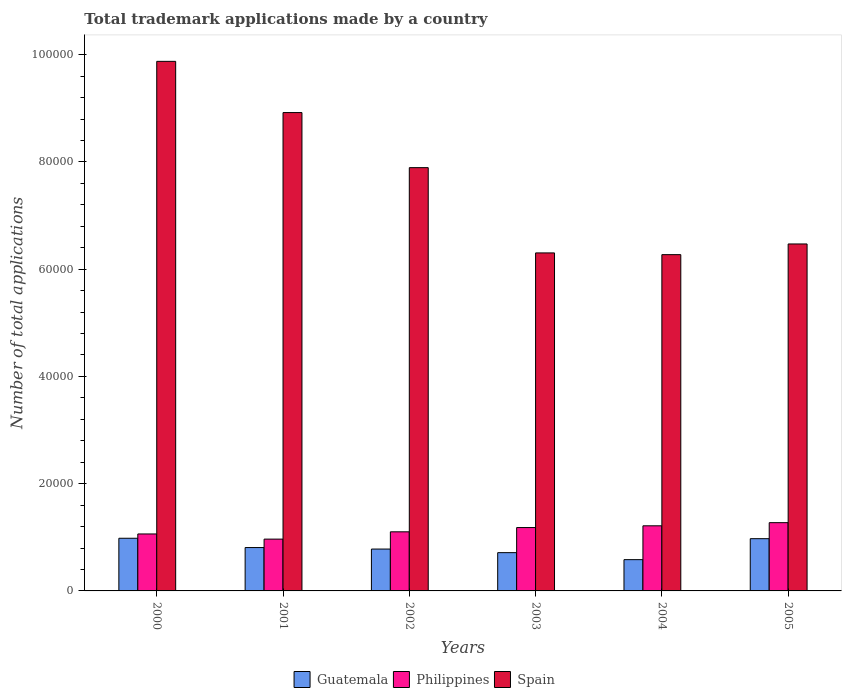Are the number of bars on each tick of the X-axis equal?
Offer a very short reply. Yes. What is the label of the 6th group of bars from the left?
Make the answer very short. 2005. What is the number of applications made by in Spain in 2003?
Provide a succinct answer. 6.30e+04. Across all years, what is the maximum number of applications made by in Guatemala?
Ensure brevity in your answer.  9821. Across all years, what is the minimum number of applications made by in Spain?
Offer a terse response. 6.27e+04. In which year was the number of applications made by in Philippines minimum?
Make the answer very short. 2001. What is the total number of applications made by in Guatemala in the graph?
Offer a terse response. 4.84e+04. What is the difference between the number of applications made by in Guatemala in 2002 and that in 2004?
Keep it short and to the point. 1976. What is the difference between the number of applications made by in Philippines in 2003 and the number of applications made by in Spain in 2002?
Make the answer very short. -6.71e+04. What is the average number of applications made by in Spain per year?
Provide a succinct answer. 7.62e+04. In the year 2004, what is the difference between the number of applications made by in Guatemala and number of applications made by in Spain?
Your answer should be compact. -5.69e+04. What is the ratio of the number of applications made by in Guatemala in 2000 to that in 2001?
Offer a terse response. 1.21. What is the difference between the highest and the second highest number of applications made by in Spain?
Offer a very short reply. 9551. What is the difference between the highest and the lowest number of applications made by in Spain?
Keep it short and to the point. 3.60e+04. In how many years, is the number of applications made by in Spain greater than the average number of applications made by in Spain taken over all years?
Make the answer very short. 3. What does the 3rd bar from the left in 2005 represents?
Provide a succinct answer. Spain. What does the 2nd bar from the right in 2005 represents?
Provide a short and direct response. Philippines. Is it the case that in every year, the sum of the number of applications made by in Guatemala and number of applications made by in Spain is greater than the number of applications made by in Philippines?
Offer a very short reply. Yes. Are all the bars in the graph horizontal?
Your response must be concise. No. What is the difference between two consecutive major ticks on the Y-axis?
Keep it short and to the point. 2.00e+04. How are the legend labels stacked?
Make the answer very short. Horizontal. What is the title of the graph?
Provide a succinct answer. Total trademark applications made by a country. What is the label or title of the Y-axis?
Give a very brief answer. Number of total applications. What is the Number of total applications in Guatemala in 2000?
Offer a terse response. 9821. What is the Number of total applications in Philippines in 2000?
Ensure brevity in your answer.  1.06e+04. What is the Number of total applications of Spain in 2000?
Your response must be concise. 9.88e+04. What is the Number of total applications of Guatemala in 2001?
Keep it short and to the point. 8088. What is the Number of total applications of Philippines in 2001?
Make the answer very short. 9661. What is the Number of total applications in Spain in 2001?
Offer a very short reply. 8.92e+04. What is the Number of total applications in Guatemala in 2002?
Offer a very short reply. 7808. What is the Number of total applications of Philippines in 2002?
Your answer should be compact. 1.10e+04. What is the Number of total applications in Spain in 2002?
Your answer should be very brief. 7.89e+04. What is the Number of total applications of Guatemala in 2003?
Offer a terse response. 7138. What is the Number of total applications in Philippines in 2003?
Give a very brief answer. 1.18e+04. What is the Number of total applications in Spain in 2003?
Offer a terse response. 6.30e+04. What is the Number of total applications in Guatemala in 2004?
Offer a very short reply. 5832. What is the Number of total applications in Philippines in 2004?
Provide a short and direct response. 1.21e+04. What is the Number of total applications of Spain in 2004?
Provide a short and direct response. 6.27e+04. What is the Number of total applications in Guatemala in 2005?
Give a very brief answer. 9743. What is the Number of total applications of Philippines in 2005?
Give a very brief answer. 1.27e+04. What is the Number of total applications of Spain in 2005?
Provide a succinct answer. 6.47e+04. Across all years, what is the maximum Number of total applications of Guatemala?
Offer a terse response. 9821. Across all years, what is the maximum Number of total applications in Philippines?
Offer a very short reply. 1.27e+04. Across all years, what is the maximum Number of total applications in Spain?
Your response must be concise. 9.88e+04. Across all years, what is the minimum Number of total applications in Guatemala?
Your answer should be compact. 5832. Across all years, what is the minimum Number of total applications of Philippines?
Provide a succinct answer. 9661. Across all years, what is the minimum Number of total applications of Spain?
Keep it short and to the point. 6.27e+04. What is the total Number of total applications of Guatemala in the graph?
Your response must be concise. 4.84e+04. What is the total Number of total applications of Philippines in the graph?
Make the answer very short. 6.80e+04. What is the total Number of total applications in Spain in the graph?
Your response must be concise. 4.57e+05. What is the difference between the Number of total applications of Guatemala in 2000 and that in 2001?
Provide a short and direct response. 1733. What is the difference between the Number of total applications of Philippines in 2000 and that in 2001?
Your answer should be very brief. 962. What is the difference between the Number of total applications in Spain in 2000 and that in 2001?
Ensure brevity in your answer.  9551. What is the difference between the Number of total applications in Guatemala in 2000 and that in 2002?
Provide a succinct answer. 2013. What is the difference between the Number of total applications of Philippines in 2000 and that in 2002?
Provide a short and direct response. -398. What is the difference between the Number of total applications of Spain in 2000 and that in 2002?
Offer a terse response. 1.98e+04. What is the difference between the Number of total applications of Guatemala in 2000 and that in 2003?
Your answer should be very brief. 2683. What is the difference between the Number of total applications of Philippines in 2000 and that in 2003?
Make the answer very short. -1193. What is the difference between the Number of total applications in Spain in 2000 and that in 2003?
Offer a terse response. 3.57e+04. What is the difference between the Number of total applications of Guatemala in 2000 and that in 2004?
Offer a very short reply. 3989. What is the difference between the Number of total applications in Philippines in 2000 and that in 2004?
Offer a terse response. -1519. What is the difference between the Number of total applications in Spain in 2000 and that in 2004?
Offer a very short reply. 3.60e+04. What is the difference between the Number of total applications of Philippines in 2000 and that in 2005?
Provide a short and direct response. -2106. What is the difference between the Number of total applications of Spain in 2000 and that in 2005?
Your answer should be very brief. 3.41e+04. What is the difference between the Number of total applications in Guatemala in 2001 and that in 2002?
Offer a terse response. 280. What is the difference between the Number of total applications of Philippines in 2001 and that in 2002?
Provide a short and direct response. -1360. What is the difference between the Number of total applications in Spain in 2001 and that in 2002?
Ensure brevity in your answer.  1.03e+04. What is the difference between the Number of total applications of Guatemala in 2001 and that in 2003?
Your response must be concise. 950. What is the difference between the Number of total applications in Philippines in 2001 and that in 2003?
Offer a terse response. -2155. What is the difference between the Number of total applications of Spain in 2001 and that in 2003?
Provide a succinct answer. 2.62e+04. What is the difference between the Number of total applications in Guatemala in 2001 and that in 2004?
Your answer should be very brief. 2256. What is the difference between the Number of total applications of Philippines in 2001 and that in 2004?
Provide a short and direct response. -2481. What is the difference between the Number of total applications of Spain in 2001 and that in 2004?
Your response must be concise. 2.65e+04. What is the difference between the Number of total applications in Guatemala in 2001 and that in 2005?
Keep it short and to the point. -1655. What is the difference between the Number of total applications of Philippines in 2001 and that in 2005?
Provide a short and direct response. -3068. What is the difference between the Number of total applications of Spain in 2001 and that in 2005?
Provide a short and direct response. 2.45e+04. What is the difference between the Number of total applications in Guatemala in 2002 and that in 2003?
Ensure brevity in your answer.  670. What is the difference between the Number of total applications in Philippines in 2002 and that in 2003?
Your answer should be very brief. -795. What is the difference between the Number of total applications of Spain in 2002 and that in 2003?
Give a very brief answer. 1.59e+04. What is the difference between the Number of total applications of Guatemala in 2002 and that in 2004?
Give a very brief answer. 1976. What is the difference between the Number of total applications of Philippines in 2002 and that in 2004?
Your answer should be very brief. -1121. What is the difference between the Number of total applications in Spain in 2002 and that in 2004?
Give a very brief answer. 1.62e+04. What is the difference between the Number of total applications of Guatemala in 2002 and that in 2005?
Your response must be concise. -1935. What is the difference between the Number of total applications of Philippines in 2002 and that in 2005?
Provide a short and direct response. -1708. What is the difference between the Number of total applications in Spain in 2002 and that in 2005?
Ensure brevity in your answer.  1.42e+04. What is the difference between the Number of total applications of Guatemala in 2003 and that in 2004?
Offer a terse response. 1306. What is the difference between the Number of total applications in Philippines in 2003 and that in 2004?
Offer a very short reply. -326. What is the difference between the Number of total applications of Spain in 2003 and that in 2004?
Keep it short and to the point. 323. What is the difference between the Number of total applications in Guatemala in 2003 and that in 2005?
Offer a very short reply. -2605. What is the difference between the Number of total applications of Philippines in 2003 and that in 2005?
Keep it short and to the point. -913. What is the difference between the Number of total applications of Spain in 2003 and that in 2005?
Ensure brevity in your answer.  -1670. What is the difference between the Number of total applications in Guatemala in 2004 and that in 2005?
Offer a very short reply. -3911. What is the difference between the Number of total applications of Philippines in 2004 and that in 2005?
Offer a very short reply. -587. What is the difference between the Number of total applications of Spain in 2004 and that in 2005?
Offer a very short reply. -1993. What is the difference between the Number of total applications in Guatemala in 2000 and the Number of total applications in Philippines in 2001?
Ensure brevity in your answer.  160. What is the difference between the Number of total applications of Guatemala in 2000 and the Number of total applications of Spain in 2001?
Make the answer very short. -7.94e+04. What is the difference between the Number of total applications in Philippines in 2000 and the Number of total applications in Spain in 2001?
Offer a terse response. -7.86e+04. What is the difference between the Number of total applications in Guatemala in 2000 and the Number of total applications in Philippines in 2002?
Offer a terse response. -1200. What is the difference between the Number of total applications in Guatemala in 2000 and the Number of total applications in Spain in 2002?
Your answer should be very brief. -6.91e+04. What is the difference between the Number of total applications of Philippines in 2000 and the Number of total applications of Spain in 2002?
Your answer should be very brief. -6.83e+04. What is the difference between the Number of total applications in Guatemala in 2000 and the Number of total applications in Philippines in 2003?
Provide a succinct answer. -1995. What is the difference between the Number of total applications in Guatemala in 2000 and the Number of total applications in Spain in 2003?
Ensure brevity in your answer.  -5.32e+04. What is the difference between the Number of total applications in Philippines in 2000 and the Number of total applications in Spain in 2003?
Ensure brevity in your answer.  -5.24e+04. What is the difference between the Number of total applications of Guatemala in 2000 and the Number of total applications of Philippines in 2004?
Offer a very short reply. -2321. What is the difference between the Number of total applications in Guatemala in 2000 and the Number of total applications in Spain in 2004?
Your answer should be very brief. -5.29e+04. What is the difference between the Number of total applications of Philippines in 2000 and the Number of total applications of Spain in 2004?
Your answer should be very brief. -5.21e+04. What is the difference between the Number of total applications in Guatemala in 2000 and the Number of total applications in Philippines in 2005?
Make the answer very short. -2908. What is the difference between the Number of total applications of Guatemala in 2000 and the Number of total applications of Spain in 2005?
Offer a very short reply. -5.49e+04. What is the difference between the Number of total applications in Philippines in 2000 and the Number of total applications in Spain in 2005?
Your answer should be very brief. -5.41e+04. What is the difference between the Number of total applications of Guatemala in 2001 and the Number of total applications of Philippines in 2002?
Offer a terse response. -2933. What is the difference between the Number of total applications in Guatemala in 2001 and the Number of total applications in Spain in 2002?
Offer a very short reply. -7.08e+04. What is the difference between the Number of total applications of Philippines in 2001 and the Number of total applications of Spain in 2002?
Offer a terse response. -6.93e+04. What is the difference between the Number of total applications of Guatemala in 2001 and the Number of total applications of Philippines in 2003?
Give a very brief answer. -3728. What is the difference between the Number of total applications of Guatemala in 2001 and the Number of total applications of Spain in 2003?
Offer a terse response. -5.49e+04. What is the difference between the Number of total applications in Philippines in 2001 and the Number of total applications in Spain in 2003?
Offer a terse response. -5.34e+04. What is the difference between the Number of total applications in Guatemala in 2001 and the Number of total applications in Philippines in 2004?
Keep it short and to the point. -4054. What is the difference between the Number of total applications in Guatemala in 2001 and the Number of total applications in Spain in 2004?
Offer a terse response. -5.46e+04. What is the difference between the Number of total applications in Philippines in 2001 and the Number of total applications in Spain in 2004?
Your answer should be compact. -5.30e+04. What is the difference between the Number of total applications of Guatemala in 2001 and the Number of total applications of Philippines in 2005?
Offer a very short reply. -4641. What is the difference between the Number of total applications of Guatemala in 2001 and the Number of total applications of Spain in 2005?
Your response must be concise. -5.66e+04. What is the difference between the Number of total applications of Philippines in 2001 and the Number of total applications of Spain in 2005?
Your answer should be compact. -5.50e+04. What is the difference between the Number of total applications in Guatemala in 2002 and the Number of total applications in Philippines in 2003?
Your answer should be very brief. -4008. What is the difference between the Number of total applications of Guatemala in 2002 and the Number of total applications of Spain in 2003?
Your answer should be compact. -5.52e+04. What is the difference between the Number of total applications of Philippines in 2002 and the Number of total applications of Spain in 2003?
Offer a terse response. -5.20e+04. What is the difference between the Number of total applications of Guatemala in 2002 and the Number of total applications of Philippines in 2004?
Ensure brevity in your answer.  -4334. What is the difference between the Number of total applications of Guatemala in 2002 and the Number of total applications of Spain in 2004?
Offer a very short reply. -5.49e+04. What is the difference between the Number of total applications in Philippines in 2002 and the Number of total applications in Spain in 2004?
Offer a terse response. -5.17e+04. What is the difference between the Number of total applications in Guatemala in 2002 and the Number of total applications in Philippines in 2005?
Your response must be concise. -4921. What is the difference between the Number of total applications of Guatemala in 2002 and the Number of total applications of Spain in 2005?
Your answer should be compact. -5.69e+04. What is the difference between the Number of total applications of Philippines in 2002 and the Number of total applications of Spain in 2005?
Your answer should be very brief. -5.37e+04. What is the difference between the Number of total applications of Guatemala in 2003 and the Number of total applications of Philippines in 2004?
Ensure brevity in your answer.  -5004. What is the difference between the Number of total applications in Guatemala in 2003 and the Number of total applications in Spain in 2004?
Your response must be concise. -5.56e+04. What is the difference between the Number of total applications of Philippines in 2003 and the Number of total applications of Spain in 2004?
Provide a succinct answer. -5.09e+04. What is the difference between the Number of total applications in Guatemala in 2003 and the Number of total applications in Philippines in 2005?
Provide a short and direct response. -5591. What is the difference between the Number of total applications in Guatemala in 2003 and the Number of total applications in Spain in 2005?
Make the answer very short. -5.76e+04. What is the difference between the Number of total applications in Philippines in 2003 and the Number of total applications in Spain in 2005?
Your response must be concise. -5.29e+04. What is the difference between the Number of total applications in Guatemala in 2004 and the Number of total applications in Philippines in 2005?
Your answer should be very brief. -6897. What is the difference between the Number of total applications of Guatemala in 2004 and the Number of total applications of Spain in 2005?
Give a very brief answer. -5.89e+04. What is the difference between the Number of total applications of Philippines in 2004 and the Number of total applications of Spain in 2005?
Ensure brevity in your answer.  -5.26e+04. What is the average Number of total applications in Guatemala per year?
Offer a very short reply. 8071.67. What is the average Number of total applications in Philippines per year?
Offer a very short reply. 1.13e+04. What is the average Number of total applications in Spain per year?
Keep it short and to the point. 7.62e+04. In the year 2000, what is the difference between the Number of total applications of Guatemala and Number of total applications of Philippines?
Provide a succinct answer. -802. In the year 2000, what is the difference between the Number of total applications of Guatemala and Number of total applications of Spain?
Make the answer very short. -8.89e+04. In the year 2000, what is the difference between the Number of total applications of Philippines and Number of total applications of Spain?
Ensure brevity in your answer.  -8.81e+04. In the year 2001, what is the difference between the Number of total applications of Guatemala and Number of total applications of Philippines?
Offer a very short reply. -1573. In the year 2001, what is the difference between the Number of total applications of Guatemala and Number of total applications of Spain?
Your answer should be compact. -8.11e+04. In the year 2001, what is the difference between the Number of total applications of Philippines and Number of total applications of Spain?
Provide a short and direct response. -7.95e+04. In the year 2002, what is the difference between the Number of total applications of Guatemala and Number of total applications of Philippines?
Your answer should be compact. -3213. In the year 2002, what is the difference between the Number of total applications in Guatemala and Number of total applications in Spain?
Offer a very short reply. -7.11e+04. In the year 2002, what is the difference between the Number of total applications of Philippines and Number of total applications of Spain?
Give a very brief answer. -6.79e+04. In the year 2003, what is the difference between the Number of total applications of Guatemala and Number of total applications of Philippines?
Your answer should be compact. -4678. In the year 2003, what is the difference between the Number of total applications of Guatemala and Number of total applications of Spain?
Ensure brevity in your answer.  -5.59e+04. In the year 2003, what is the difference between the Number of total applications of Philippines and Number of total applications of Spain?
Keep it short and to the point. -5.12e+04. In the year 2004, what is the difference between the Number of total applications in Guatemala and Number of total applications in Philippines?
Your answer should be very brief. -6310. In the year 2004, what is the difference between the Number of total applications of Guatemala and Number of total applications of Spain?
Offer a terse response. -5.69e+04. In the year 2004, what is the difference between the Number of total applications in Philippines and Number of total applications in Spain?
Your answer should be compact. -5.06e+04. In the year 2005, what is the difference between the Number of total applications in Guatemala and Number of total applications in Philippines?
Offer a very short reply. -2986. In the year 2005, what is the difference between the Number of total applications in Guatemala and Number of total applications in Spain?
Your answer should be compact. -5.50e+04. In the year 2005, what is the difference between the Number of total applications of Philippines and Number of total applications of Spain?
Your answer should be compact. -5.20e+04. What is the ratio of the Number of total applications in Guatemala in 2000 to that in 2001?
Keep it short and to the point. 1.21. What is the ratio of the Number of total applications in Philippines in 2000 to that in 2001?
Your answer should be very brief. 1.1. What is the ratio of the Number of total applications of Spain in 2000 to that in 2001?
Provide a short and direct response. 1.11. What is the ratio of the Number of total applications of Guatemala in 2000 to that in 2002?
Provide a succinct answer. 1.26. What is the ratio of the Number of total applications in Philippines in 2000 to that in 2002?
Offer a very short reply. 0.96. What is the ratio of the Number of total applications in Spain in 2000 to that in 2002?
Offer a terse response. 1.25. What is the ratio of the Number of total applications of Guatemala in 2000 to that in 2003?
Keep it short and to the point. 1.38. What is the ratio of the Number of total applications in Philippines in 2000 to that in 2003?
Your answer should be compact. 0.9. What is the ratio of the Number of total applications in Spain in 2000 to that in 2003?
Ensure brevity in your answer.  1.57. What is the ratio of the Number of total applications in Guatemala in 2000 to that in 2004?
Ensure brevity in your answer.  1.68. What is the ratio of the Number of total applications in Philippines in 2000 to that in 2004?
Offer a very short reply. 0.87. What is the ratio of the Number of total applications of Spain in 2000 to that in 2004?
Provide a succinct answer. 1.57. What is the ratio of the Number of total applications in Guatemala in 2000 to that in 2005?
Give a very brief answer. 1.01. What is the ratio of the Number of total applications in Philippines in 2000 to that in 2005?
Make the answer very short. 0.83. What is the ratio of the Number of total applications in Spain in 2000 to that in 2005?
Make the answer very short. 1.53. What is the ratio of the Number of total applications of Guatemala in 2001 to that in 2002?
Offer a very short reply. 1.04. What is the ratio of the Number of total applications of Philippines in 2001 to that in 2002?
Make the answer very short. 0.88. What is the ratio of the Number of total applications in Spain in 2001 to that in 2002?
Offer a terse response. 1.13. What is the ratio of the Number of total applications of Guatemala in 2001 to that in 2003?
Give a very brief answer. 1.13. What is the ratio of the Number of total applications of Philippines in 2001 to that in 2003?
Make the answer very short. 0.82. What is the ratio of the Number of total applications in Spain in 2001 to that in 2003?
Your answer should be very brief. 1.42. What is the ratio of the Number of total applications in Guatemala in 2001 to that in 2004?
Provide a succinct answer. 1.39. What is the ratio of the Number of total applications of Philippines in 2001 to that in 2004?
Offer a very short reply. 0.8. What is the ratio of the Number of total applications in Spain in 2001 to that in 2004?
Provide a succinct answer. 1.42. What is the ratio of the Number of total applications of Guatemala in 2001 to that in 2005?
Give a very brief answer. 0.83. What is the ratio of the Number of total applications in Philippines in 2001 to that in 2005?
Keep it short and to the point. 0.76. What is the ratio of the Number of total applications of Spain in 2001 to that in 2005?
Your answer should be compact. 1.38. What is the ratio of the Number of total applications in Guatemala in 2002 to that in 2003?
Make the answer very short. 1.09. What is the ratio of the Number of total applications of Philippines in 2002 to that in 2003?
Give a very brief answer. 0.93. What is the ratio of the Number of total applications in Spain in 2002 to that in 2003?
Offer a very short reply. 1.25. What is the ratio of the Number of total applications of Guatemala in 2002 to that in 2004?
Offer a terse response. 1.34. What is the ratio of the Number of total applications in Philippines in 2002 to that in 2004?
Offer a very short reply. 0.91. What is the ratio of the Number of total applications of Spain in 2002 to that in 2004?
Your response must be concise. 1.26. What is the ratio of the Number of total applications in Guatemala in 2002 to that in 2005?
Make the answer very short. 0.8. What is the ratio of the Number of total applications of Philippines in 2002 to that in 2005?
Keep it short and to the point. 0.87. What is the ratio of the Number of total applications of Spain in 2002 to that in 2005?
Your answer should be compact. 1.22. What is the ratio of the Number of total applications of Guatemala in 2003 to that in 2004?
Provide a short and direct response. 1.22. What is the ratio of the Number of total applications in Philippines in 2003 to that in 2004?
Keep it short and to the point. 0.97. What is the ratio of the Number of total applications of Spain in 2003 to that in 2004?
Your response must be concise. 1.01. What is the ratio of the Number of total applications in Guatemala in 2003 to that in 2005?
Make the answer very short. 0.73. What is the ratio of the Number of total applications of Philippines in 2003 to that in 2005?
Make the answer very short. 0.93. What is the ratio of the Number of total applications in Spain in 2003 to that in 2005?
Give a very brief answer. 0.97. What is the ratio of the Number of total applications in Guatemala in 2004 to that in 2005?
Your response must be concise. 0.6. What is the ratio of the Number of total applications in Philippines in 2004 to that in 2005?
Your answer should be very brief. 0.95. What is the ratio of the Number of total applications in Spain in 2004 to that in 2005?
Provide a succinct answer. 0.97. What is the difference between the highest and the second highest Number of total applications in Guatemala?
Your response must be concise. 78. What is the difference between the highest and the second highest Number of total applications of Philippines?
Give a very brief answer. 587. What is the difference between the highest and the second highest Number of total applications in Spain?
Provide a short and direct response. 9551. What is the difference between the highest and the lowest Number of total applications of Guatemala?
Offer a terse response. 3989. What is the difference between the highest and the lowest Number of total applications in Philippines?
Offer a terse response. 3068. What is the difference between the highest and the lowest Number of total applications in Spain?
Give a very brief answer. 3.60e+04. 